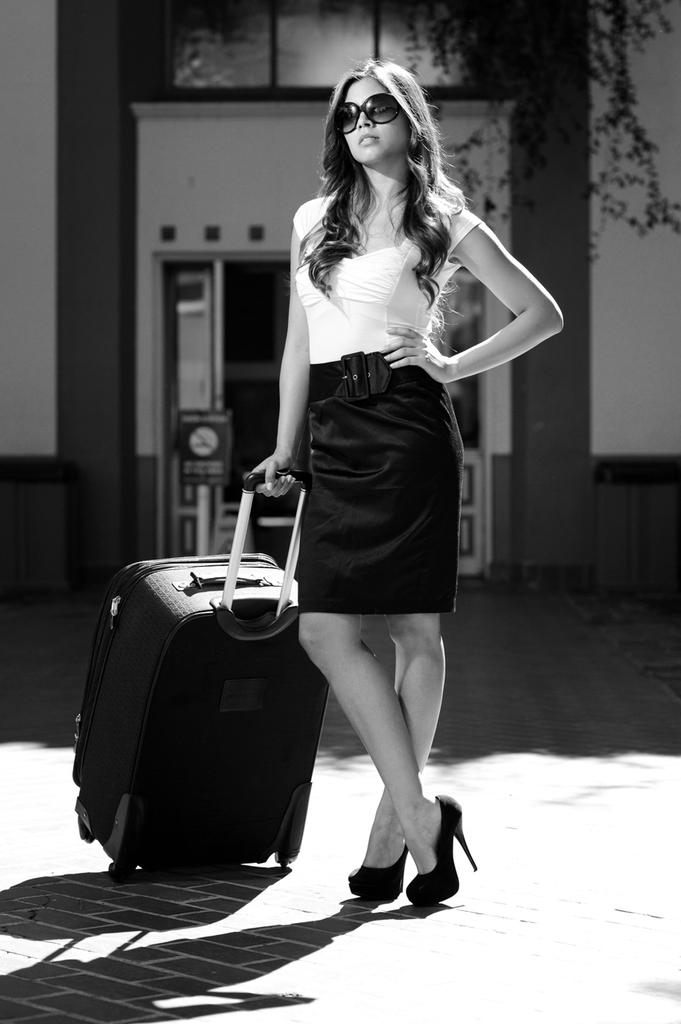Who is the main subject in the image? There is a woman in the image. What is the woman holding in the image? The woman is holding a trolley. What accessory is the woman wearing in the image? The woman is wearing glasses. What can be seen in the background of the image? There is a building in the background of the image. What type of yoke is the woman using to manage the trolley in the image? There is no yoke present in the image, and the woman is not managing the trolley; she is simply holding it. 